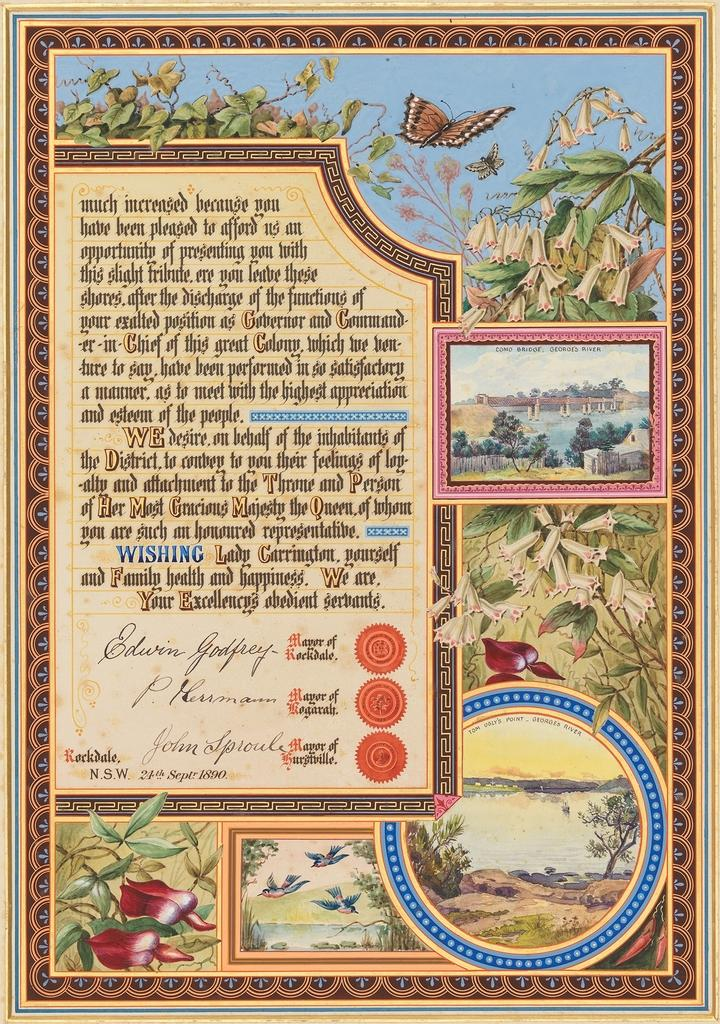<image>
Provide a brief description of the given image. A letter from mayors that is dated from the 24th of September in 1890. 